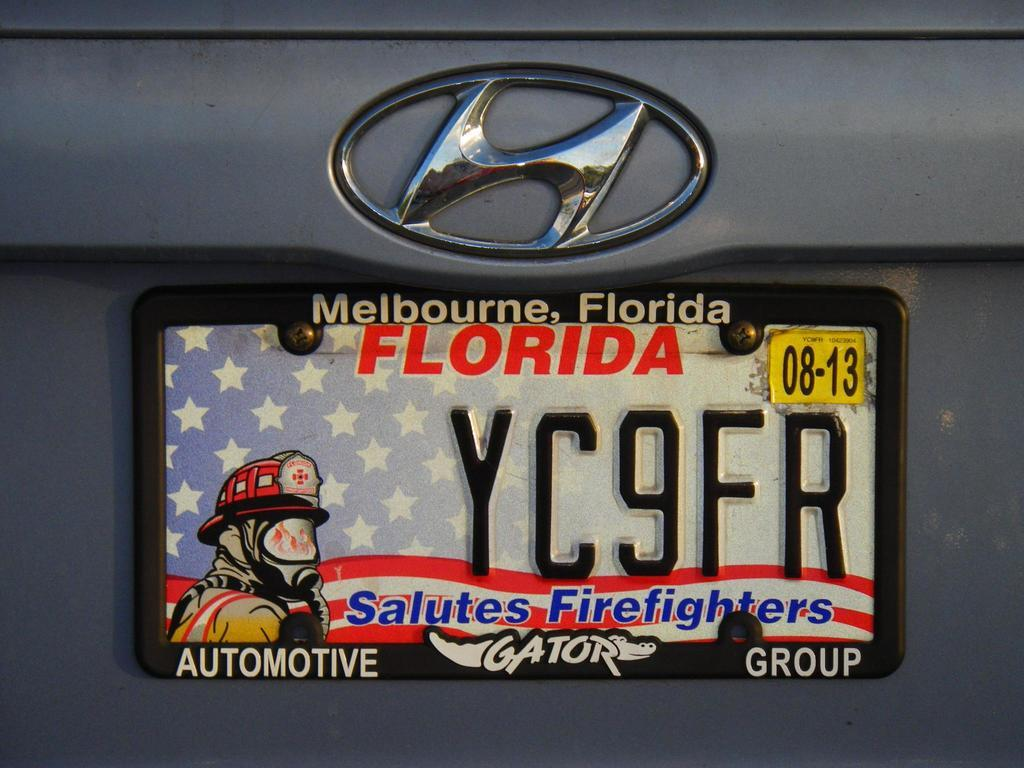<image>
Relay a brief, clear account of the picture shown. A Florida license place with the words "Salutes Firefighters" at the bottom. 